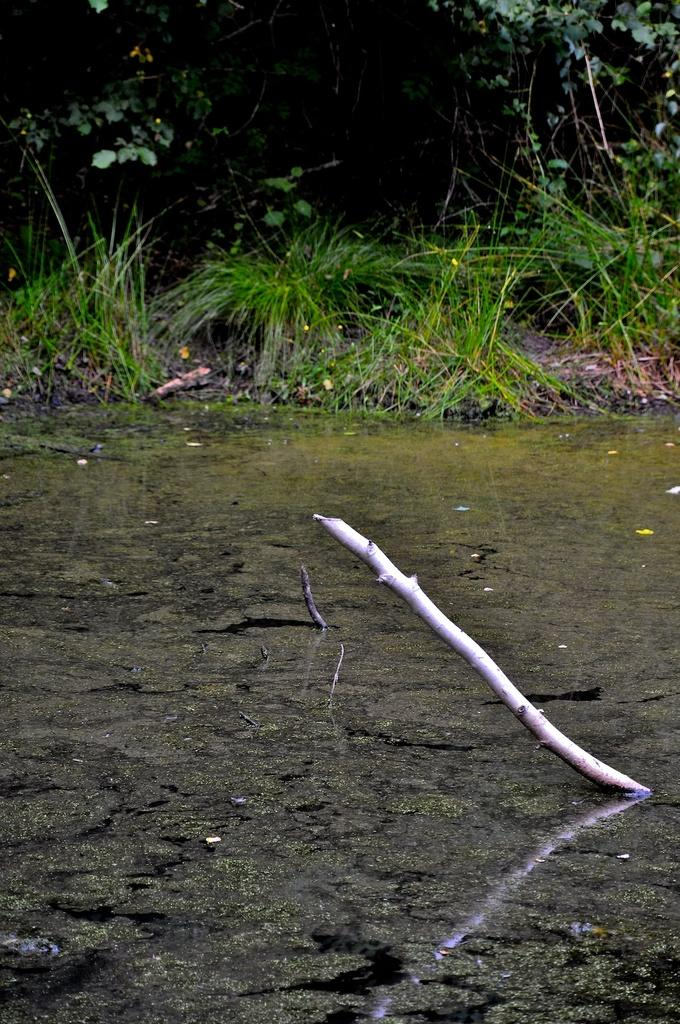What object can be seen in the image that is long and thin? There is a stick in the image. What natural element is present in the image? There is water in the image. What type of vegetation is visible in the image? There is grass in the image. What type of large plants can be seen in the image? There are trees in the image. How does the stick help to alleviate the pain in the image? There is no indication of pain in the image, and the stick is not shown to be used for any therapeutic purpose. 